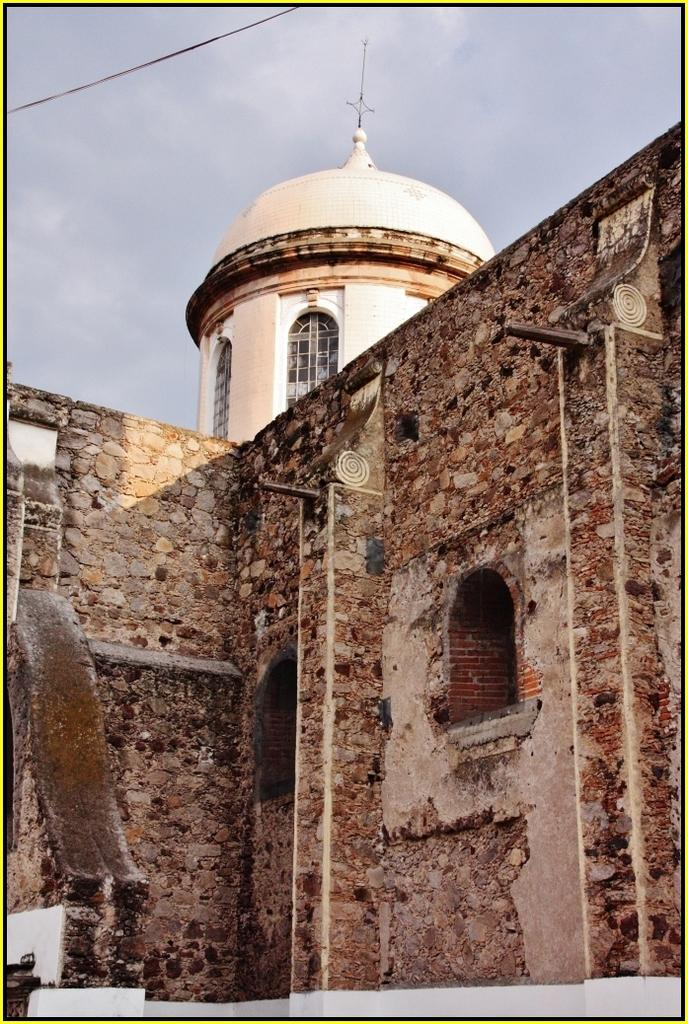What structure is present in the image? There is a building in the image. What feature can be seen on the building? There are windows in the building. What type of material is used for the building's wall? The building has a brick wall. What is the color of the sky in the image? The sky is blue and white in color. Can you tell me how many pins are holding the building together in the image? There is no mention of pins in the image, and they are not necessary for holding a building together. What type of bulb is illuminating the building in the image? There is no specific type of bulb mentioned or visible in the image. 